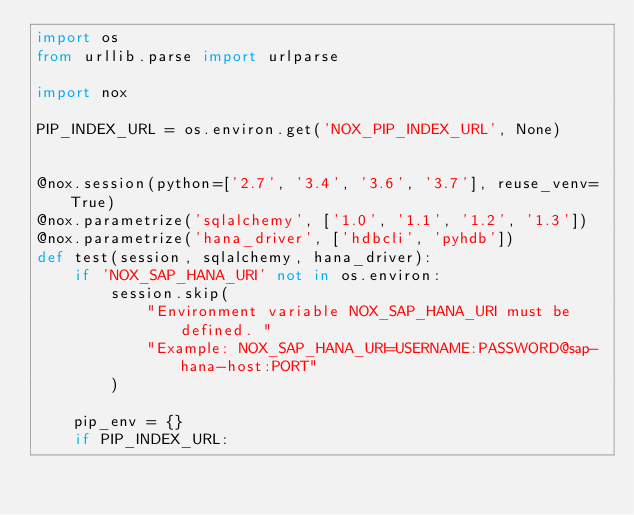<code> <loc_0><loc_0><loc_500><loc_500><_Python_>import os
from urllib.parse import urlparse

import nox

PIP_INDEX_URL = os.environ.get('NOX_PIP_INDEX_URL', None)


@nox.session(python=['2.7', '3.4', '3.6', '3.7'], reuse_venv=True)
@nox.parametrize('sqlalchemy', ['1.0', '1.1', '1.2', '1.3'])
@nox.parametrize('hana_driver', ['hdbcli', 'pyhdb'])
def test(session, sqlalchemy, hana_driver):
    if 'NOX_SAP_HANA_URI' not in os.environ:
        session.skip(
            "Environment variable NOX_SAP_HANA_URI must be defined. "
            "Example: NOX_SAP_HANA_URI=USERNAME:PASSWORD@sap-hana-host:PORT"
        )

    pip_env = {}
    if PIP_INDEX_URL:</code> 